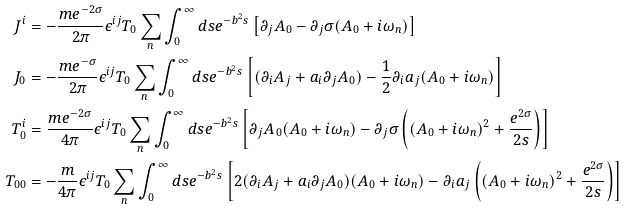<formula> <loc_0><loc_0><loc_500><loc_500>J ^ { i } & = - \frac { m e ^ { - 2 \sigma } } { 2 \pi } \epsilon ^ { i j } T _ { 0 } \sum _ { n } \int _ { 0 } ^ { \infty } d s e ^ { - b ^ { 2 } s } \left [ \partial _ { j } A _ { 0 } - \partial _ { j } \sigma ( A _ { 0 } + i \omega _ { n } ) \right ] \\ J _ { 0 } & = - \frac { m e ^ { - \sigma } } { 2 \pi } \epsilon ^ { i j } T _ { 0 } \sum _ { n } \int _ { 0 } ^ { \infty } d s e ^ { - b ^ { 2 } s } \left [ ( \partial _ { i } A _ { j } + a _ { i } \partial _ { j } A _ { 0 } ) - \frac { 1 } { 2 } \partial _ { i } a _ { j } ( A _ { 0 } + i \omega _ { n } ) \right ] \\ T _ { 0 } ^ { i } & = \frac { m e ^ { - 2 \sigma } } { 4 \pi } \epsilon ^ { i j } T _ { 0 } \sum _ { n } \int _ { 0 } ^ { \infty } d s e ^ { - b ^ { 2 } s } \left [ \partial _ { j } A _ { 0 } ( A _ { 0 } + i \omega _ { n } ) - \partial _ { j } \sigma \left ( ( A _ { 0 } + i \omega _ { n } ) ^ { 2 } + \frac { e ^ { 2 \sigma } } { 2 s } \right ) \right ] \\ T _ { 0 0 } & = - \frac { m } { 4 \pi } \epsilon ^ { i j } T _ { 0 } \sum _ { n } \int _ { 0 } ^ { \infty } d s e ^ { - b ^ { 2 } s } \left [ 2 ( \partial _ { i } A _ { j } + a _ { i } \partial _ { j } A _ { 0 } ) ( A _ { 0 } + i \omega _ { n } ) - \partial _ { i } a _ { j } \left ( ( A _ { 0 } + i \omega _ { n } ) ^ { 2 } + \frac { e ^ { 2 \sigma } } { 2 s } \right ) \right ] \\</formula> 